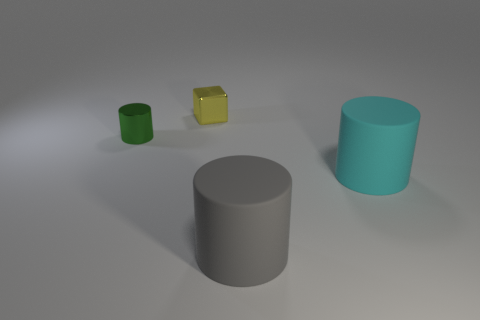Subtract all green cylinders. How many cylinders are left? 2 Add 4 yellow metal objects. How many objects exist? 8 Subtract all green cylinders. How many cylinders are left? 2 Subtract 1 blocks. How many blocks are left? 0 Subtract all cubes. How many objects are left? 3 Subtract all gray cubes. How many cyan cylinders are left? 1 Subtract all purple cubes. Subtract all small cylinders. How many objects are left? 3 Add 4 metal cubes. How many metal cubes are left? 5 Add 2 small yellow shiny blocks. How many small yellow shiny blocks exist? 3 Subtract 0 green balls. How many objects are left? 4 